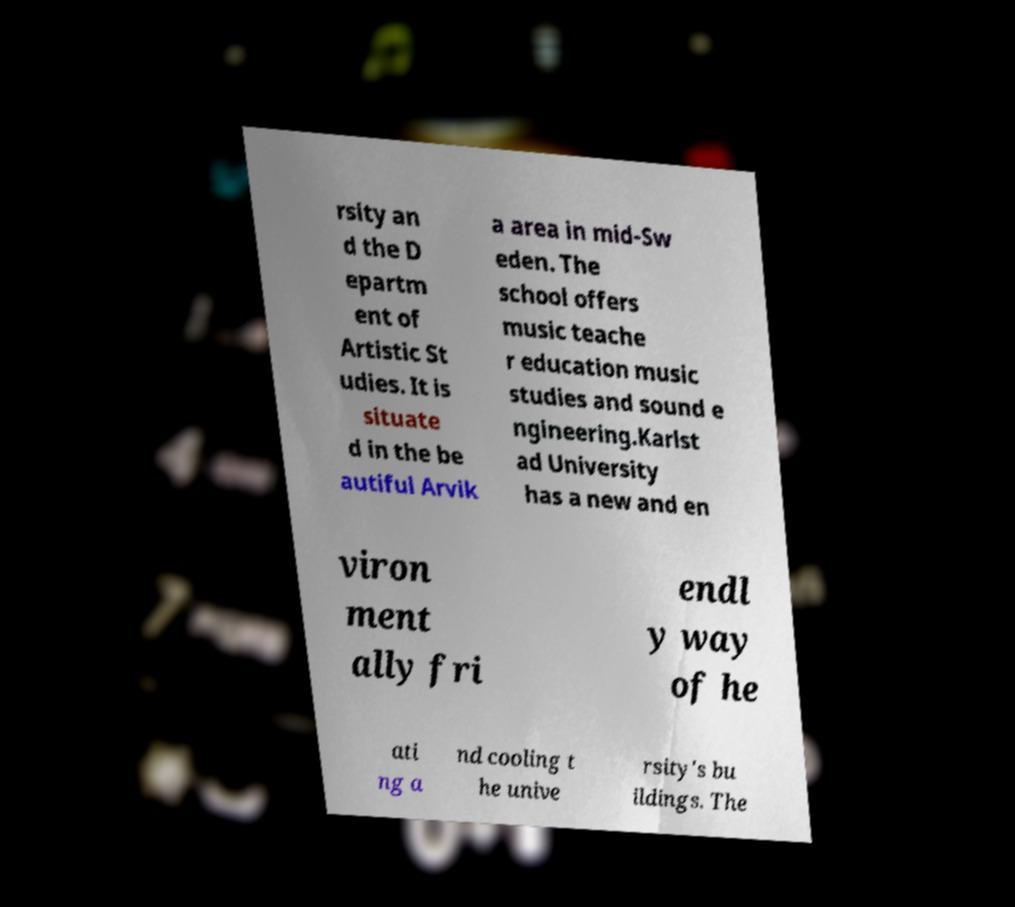I need the written content from this picture converted into text. Can you do that? rsity an d the D epartm ent of Artistic St udies. It is situate d in the be autiful Arvik a area in mid-Sw eden. The school offers music teache r education music studies and sound e ngineering.Karlst ad University has a new and en viron ment ally fri endl y way of he ati ng a nd cooling t he unive rsity's bu ildings. The 